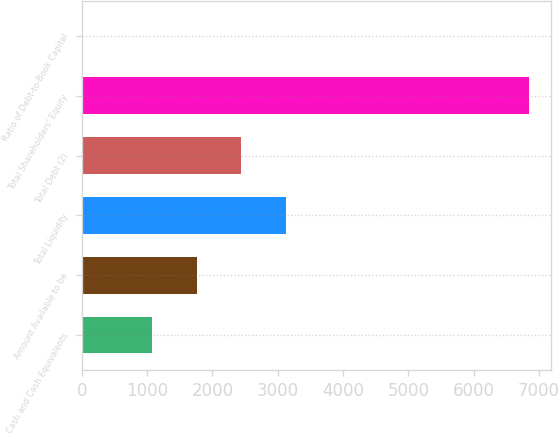Convert chart. <chart><loc_0><loc_0><loc_500><loc_500><bar_chart><fcel>Cash and Cash Equivalents<fcel>Amount Available to be<fcel>Total Liquidity<fcel>Total Debt (2)<fcel>Total Shareholders' Equity<fcel>Ratio of Debt-to-Book Capital<nl><fcel>1081<fcel>1763.3<fcel>3127.9<fcel>2445.6<fcel>6848<fcel>25<nl></chart> 